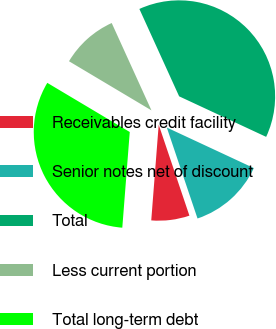Convert chart to OTSL. <chart><loc_0><loc_0><loc_500><loc_500><pie_chart><fcel>Receivables credit facility<fcel>Senior notes net of discount<fcel>Total<fcel>Less current portion<fcel>Total long-term debt<nl><fcel>6.42%<fcel>12.88%<fcel>38.74%<fcel>9.65%<fcel>32.32%<nl></chart> 